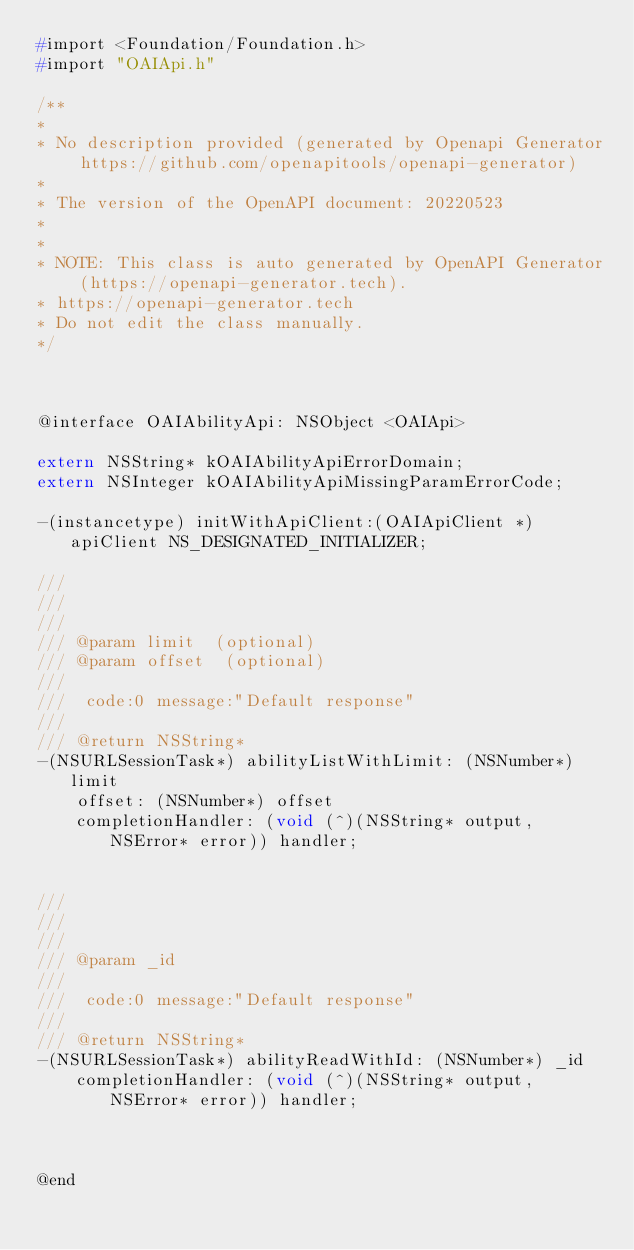<code> <loc_0><loc_0><loc_500><loc_500><_C_>#import <Foundation/Foundation.h>
#import "OAIApi.h"

/**
* 
* No description provided (generated by Openapi Generator https://github.com/openapitools/openapi-generator)
*
* The version of the OpenAPI document: 20220523
* 
*
* NOTE: This class is auto generated by OpenAPI Generator (https://openapi-generator.tech).
* https://openapi-generator.tech
* Do not edit the class manually.
*/



@interface OAIAbilityApi: NSObject <OAIApi>

extern NSString* kOAIAbilityApiErrorDomain;
extern NSInteger kOAIAbilityApiMissingParamErrorCode;

-(instancetype) initWithApiClient:(OAIApiClient *)apiClient NS_DESIGNATED_INITIALIZER;

/// 
/// 
///
/// @param limit  (optional)
/// @param offset  (optional)
/// 
///  code:0 message:"Default response"
///
/// @return NSString*
-(NSURLSessionTask*) abilityListWithLimit: (NSNumber*) limit
    offset: (NSNumber*) offset
    completionHandler: (void (^)(NSString* output, NSError* error)) handler;


/// 
/// 
///
/// @param _id 
/// 
///  code:0 message:"Default response"
///
/// @return NSString*
-(NSURLSessionTask*) abilityReadWithId: (NSNumber*) _id
    completionHandler: (void (^)(NSString* output, NSError* error)) handler;



@end
</code> 